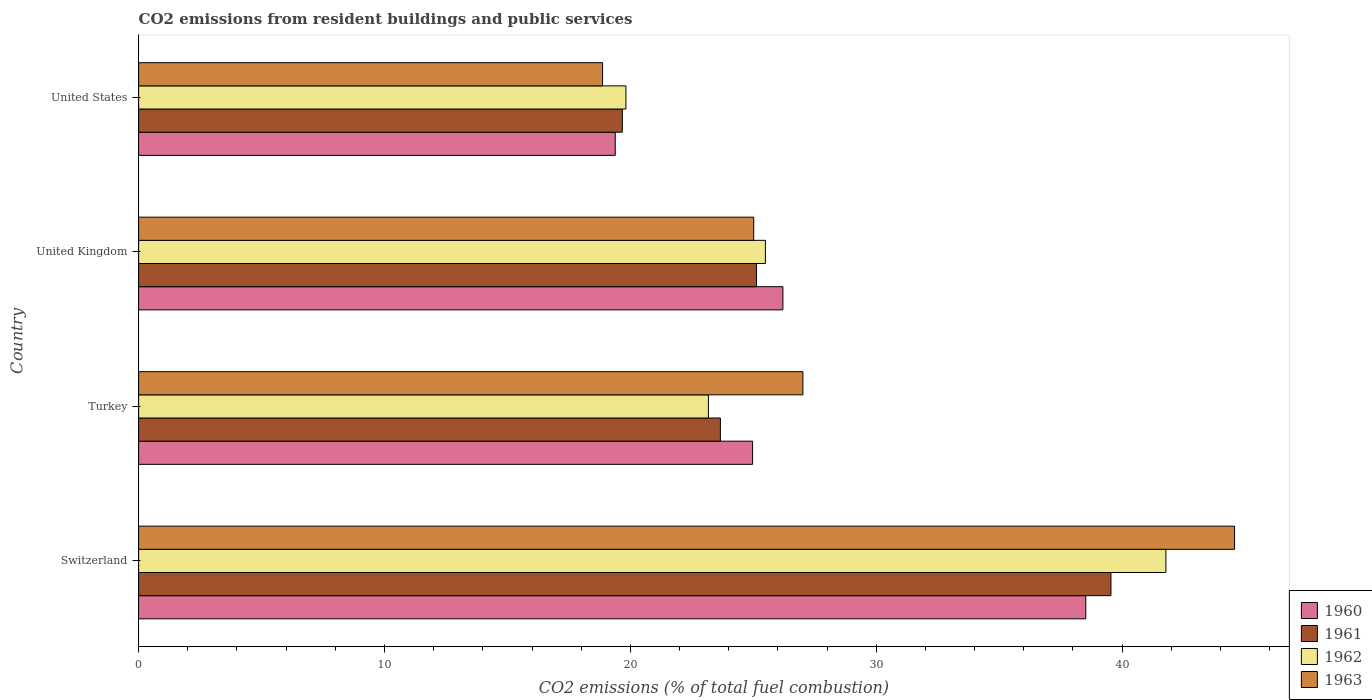How many groups of bars are there?
Make the answer very short. 4. Are the number of bars per tick equal to the number of legend labels?
Keep it short and to the point. Yes. Are the number of bars on each tick of the Y-axis equal?
Offer a terse response. Yes. How many bars are there on the 1st tick from the bottom?
Offer a terse response. 4. In how many cases, is the number of bars for a given country not equal to the number of legend labels?
Provide a short and direct response. 0. What is the total CO2 emitted in 1963 in Switzerland?
Offer a terse response. 44.57. Across all countries, what is the maximum total CO2 emitted in 1960?
Ensure brevity in your answer.  38.52. Across all countries, what is the minimum total CO2 emitted in 1962?
Give a very brief answer. 19.82. In which country was the total CO2 emitted in 1960 maximum?
Your response must be concise. Switzerland. What is the total total CO2 emitted in 1963 in the graph?
Keep it short and to the point. 115.47. What is the difference between the total CO2 emitted in 1961 in Turkey and that in United States?
Give a very brief answer. 3.99. What is the difference between the total CO2 emitted in 1962 in Switzerland and the total CO2 emitted in 1963 in Turkey?
Your answer should be compact. 14.76. What is the average total CO2 emitted in 1962 per country?
Give a very brief answer. 27.57. What is the difference between the total CO2 emitted in 1961 and total CO2 emitted in 1963 in Switzerland?
Your response must be concise. -5.03. What is the ratio of the total CO2 emitted in 1963 in Turkey to that in United Kingdom?
Your response must be concise. 1.08. Is the total CO2 emitted in 1962 in Switzerland less than that in Turkey?
Provide a short and direct response. No. Is the difference between the total CO2 emitted in 1961 in Switzerland and United Kingdom greater than the difference between the total CO2 emitted in 1963 in Switzerland and United Kingdom?
Ensure brevity in your answer.  No. What is the difference between the highest and the second highest total CO2 emitted in 1962?
Your answer should be compact. 16.29. What is the difference between the highest and the lowest total CO2 emitted in 1960?
Offer a very short reply. 19.14. Is it the case that in every country, the sum of the total CO2 emitted in 1962 and total CO2 emitted in 1961 is greater than the total CO2 emitted in 1960?
Your answer should be compact. Yes. What is the difference between two consecutive major ticks on the X-axis?
Provide a short and direct response. 10. Does the graph contain grids?
Your answer should be compact. No. How are the legend labels stacked?
Give a very brief answer. Vertical. What is the title of the graph?
Provide a short and direct response. CO2 emissions from resident buildings and public services. Does "1960" appear as one of the legend labels in the graph?
Ensure brevity in your answer.  Yes. What is the label or title of the X-axis?
Keep it short and to the point. CO2 emissions (% of total fuel combustion). What is the CO2 emissions (% of total fuel combustion) in 1960 in Switzerland?
Provide a succinct answer. 38.52. What is the CO2 emissions (% of total fuel combustion) in 1961 in Switzerland?
Offer a very short reply. 39.54. What is the CO2 emissions (% of total fuel combustion) of 1962 in Switzerland?
Make the answer very short. 41.78. What is the CO2 emissions (% of total fuel combustion) in 1963 in Switzerland?
Your answer should be very brief. 44.57. What is the CO2 emissions (% of total fuel combustion) in 1960 in Turkey?
Provide a succinct answer. 24.97. What is the CO2 emissions (% of total fuel combustion) of 1961 in Turkey?
Ensure brevity in your answer.  23.66. What is the CO2 emissions (% of total fuel combustion) in 1962 in Turkey?
Ensure brevity in your answer.  23.17. What is the CO2 emissions (% of total fuel combustion) in 1963 in Turkey?
Offer a very short reply. 27.01. What is the CO2 emissions (% of total fuel combustion) in 1960 in United Kingdom?
Offer a very short reply. 26.2. What is the CO2 emissions (% of total fuel combustion) of 1961 in United Kingdom?
Give a very brief answer. 25.13. What is the CO2 emissions (% of total fuel combustion) of 1962 in United Kingdom?
Provide a short and direct response. 25.49. What is the CO2 emissions (% of total fuel combustion) of 1963 in United Kingdom?
Your answer should be compact. 25.01. What is the CO2 emissions (% of total fuel combustion) in 1960 in United States?
Ensure brevity in your answer.  19.38. What is the CO2 emissions (% of total fuel combustion) of 1961 in United States?
Offer a terse response. 19.67. What is the CO2 emissions (% of total fuel combustion) in 1962 in United States?
Provide a succinct answer. 19.82. What is the CO2 emissions (% of total fuel combustion) in 1963 in United States?
Provide a succinct answer. 18.87. Across all countries, what is the maximum CO2 emissions (% of total fuel combustion) of 1960?
Provide a succinct answer. 38.52. Across all countries, what is the maximum CO2 emissions (% of total fuel combustion) in 1961?
Your answer should be compact. 39.54. Across all countries, what is the maximum CO2 emissions (% of total fuel combustion) in 1962?
Your response must be concise. 41.78. Across all countries, what is the maximum CO2 emissions (% of total fuel combustion) in 1963?
Ensure brevity in your answer.  44.57. Across all countries, what is the minimum CO2 emissions (% of total fuel combustion) of 1960?
Your response must be concise. 19.38. Across all countries, what is the minimum CO2 emissions (% of total fuel combustion) of 1961?
Your response must be concise. 19.67. Across all countries, what is the minimum CO2 emissions (% of total fuel combustion) of 1962?
Make the answer very short. 19.82. Across all countries, what is the minimum CO2 emissions (% of total fuel combustion) in 1963?
Give a very brief answer. 18.87. What is the total CO2 emissions (% of total fuel combustion) in 1960 in the graph?
Ensure brevity in your answer.  109.08. What is the total CO2 emissions (% of total fuel combustion) of 1961 in the graph?
Your response must be concise. 108. What is the total CO2 emissions (% of total fuel combustion) of 1962 in the graph?
Provide a short and direct response. 110.26. What is the total CO2 emissions (% of total fuel combustion) in 1963 in the graph?
Keep it short and to the point. 115.47. What is the difference between the CO2 emissions (% of total fuel combustion) in 1960 in Switzerland and that in Turkey?
Provide a short and direct response. 13.55. What is the difference between the CO2 emissions (% of total fuel combustion) in 1961 in Switzerland and that in Turkey?
Your answer should be compact. 15.88. What is the difference between the CO2 emissions (% of total fuel combustion) in 1962 in Switzerland and that in Turkey?
Provide a succinct answer. 18.6. What is the difference between the CO2 emissions (% of total fuel combustion) of 1963 in Switzerland and that in Turkey?
Offer a terse response. 17.56. What is the difference between the CO2 emissions (% of total fuel combustion) of 1960 in Switzerland and that in United Kingdom?
Give a very brief answer. 12.32. What is the difference between the CO2 emissions (% of total fuel combustion) in 1961 in Switzerland and that in United Kingdom?
Keep it short and to the point. 14.42. What is the difference between the CO2 emissions (% of total fuel combustion) of 1962 in Switzerland and that in United Kingdom?
Provide a succinct answer. 16.29. What is the difference between the CO2 emissions (% of total fuel combustion) of 1963 in Switzerland and that in United Kingdom?
Give a very brief answer. 19.56. What is the difference between the CO2 emissions (% of total fuel combustion) in 1960 in Switzerland and that in United States?
Your answer should be very brief. 19.14. What is the difference between the CO2 emissions (% of total fuel combustion) in 1961 in Switzerland and that in United States?
Your answer should be compact. 19.87. What is the difference between the CO2 emissions (% of total fuel combustion) of 1962 in Switzerland and that in United States?
Your answer should be very brief. 21.96. What is the difference between the CO2 emissions (% of total fuel combustion) of 1963 in Switzerland and that in United States?
Your response must be concise. 25.7. What is the difference between the CO2 emissions (% of total fuel combustion) in 1960 in Turkey and that in United Kingdom?
Your answer should be compact. -1.23. What is the difference between the CO2 emissions (% of total fuel combustion) of 1961 in Turkey and that in United Kingdom?
Give a very brief answer. -1.47. What is the difference between the CO2 emissions (% of total fuel combustion) in 1962 in Turkey and that in United Kingdom?
Offer a terse response. -2.32. What is the difference between the CO2 emissions (% of total fuel combustion) in 1960 in Turkey and that in United States?
Your answer should be very brief. 5.59. What is the difference between the CO2 emissions (% of total fuel combustion) of 1961 in Turkey and that in United States?
Offer a terse response. 3.99. What is the difference between the CO2 emissions (% of total fuel combustion) in 1962 in Turkey and that in United States?
Provide a short and direct response. 3.36. What is the difference between the CO2 emissions (% of total fuel combustion) of 1963 in Turkey and that in United States?
Provide a short and direct response. 8.15. What is the difference between the CO2 emissions (% of total fuel combustion) in 1960 in United Kingdom and that in United States?
Keep it short and to the point. 6.82. What is the difference between the CO2 emissions (% of total fuel combustion) in 1961 in United Kingdom and that in United States?
Your answer should be compact. 5.46. What is the difference between the CO2 emissions (% of total fuel combustion) of 1962 in United Kingdom and that in United States?
Make the answer very short. 5.67. What is the difference between the CO2 emissions (% of total fuel combustion) in 1963 in United Kingdom and that in United States?
Offer a terse response. 6.15. What is the difference between the CO2 emissions (% of total fuel combustion) of 1960 in Switzerland and the CO2 emissions (% of total fuel combustion) of 1961 in Turkey?
Provide a succinct answer. 14.86. What is the difference between the CO2 emissions (% of total fuel combustion) in 1960 in Switzerland and the CO2 emissions (% of total fuel combustion) in 1962 in Turkey?
Your response must be concise. 15.35. What is the difference between the CO2 emissions (% of total fuel combustion) in 1960 in Switzerland and the CO2 emissions (% of total fuel combustion) in 1963 in Turkey?
Offer a very short reply. 11.51. What is the difference between the CO2 emissions (% of total fuel combustion) of 1961 in Switzerland and the CO2 emissions (% of total fuel combustion) of 1962 in Turkey?
Offer a terse response. 16.37. What is the difference between the CO2 emissions (% of total fuel combustion) of 1961 in Switzerland and the CO2 emissions (% of total fuel combustion) of 1963 in Turkey?
Provide a succinct answer. 12.53. What is the difference between the CO2 emissions (% of total fuel combustion) of 1962 in Switzerland and the CO2 emissions (% of total fuel combustion) of 1963 in Turkey?
Offer a terse response. 14.76. What is the difference between the CO2 emissions (% of total fuel combustion) of 1960 in Switzerland and the CO2 emissions (% of total fuel combustion) of 1961 in United Kingdom?
Keep it short and to the point. 13.39. What is the difference between the CO2 emissions (% of total fuel combustion) of 1960 in Switzerland and the CO2 emissions (% of total fuel combustion) of 1962 in United Kingdom?
Make the answer very short. 13.03. What is the difference between the CO2 emissions (% of total fuel combustion) of 1960 in Switzerland and the CO2 emissions (% of total fuel combustion) of 1963 in United Kingdom?
Your answer should be very brief. 13.51. What is the difference between the CO2 emissions (% of total fuel combustion) of 1961 in Switzerland and the CO2 emissions (% of total fuel combustion) of 1962 in United Kingdom?
Provide a short and direct response. 14.05. What is the difference between the CO2 emissions (% of total fuel combustion) in 1961 in Switzerland and the CO2 emissions (% of total fuel combustion) in 1963 in United Kingdom?
Offer a terse response. 14.53. What is the difference between the CO2 emissions (% of total fuel combustion) of 1962 in Switzerland and the CO2 emissions (% of total fuel combustion) of 1963 in United Kingdom?
Make the answer very short. 16.76. What is the difference between the CO2 emissions (% of total fuel combustion) in 1960 in Switzerland and the CO2 emissions (% of total fuel combustion) in 1961 in United States?
Ensure brevity in your answer.  18.85. What is the difference between the CO2 emissions (% of total fuel combustion) of 1960 in Switzerland and the CO2 emissions (% of total fuel combustion) of 1962 in United States?
Keep it short and to the point. 18.7. What is the difference between the CO2 emissions (% of total fuel combustion) in 1960 in Switzerland and the CO2 emissions (% of total fuel combustion) in 1963 in United States?
Provide a short and direct response. 19.65. What is the difference between the CO2 emissions (% of total fuel combustion) of 1961 in Switzerland and the CO2 emissions (% of total fuel combustion) of 1962 in United States?
Keep it short and to the point. 19.73. What is the difference between the CO2 emissions (% of total fuel combustion) of 1961 in Switzerland and the CO2 emissions (% of total fuel combustion) of 1963 in United States?
Make the answer very short. 20.68. What is the difference between the CO2 emissions (% of total fuel combustion) of 1962 in Switzerland and the CO2 emissions (% of total fuel combustion) of 1963 in United States?
Ensure brevity in your answer.  22.91. What is the difference between the CO2 emissions (% of total fuel combustion) in 1960 in Turkey and the CO2 emissions (% of total fuel combustion) in 1961 in United Kingdom?
Give a very brief answer. -0.16. What is the difference between the CO2 emissions (% of total fuel combustion) of 1960 in Turkey and the CO2 emissions (% of total fuel combustion) of 1962 in United Kingdom?
Give a very brief answer. -0.52. What is the difference between the CO2 emissions (% of total fuel combustion) of 1960 in Turkey and the CO2 emissions (% of total fuel combustion) of 1963 in United Kingdom?
Your answer should be compact. -0.05. What is the difference between the CO2 emissions (% of total fuel combustion) of 1961 in Turkey and the CO2 emissions (% of total fuel combustion) of 1962 in United Kingdom?
Your answer should be compact. -1.83. What is the difference between the CO2 emissions (% of total fuel combustion) of 1961 in Turkey and the CO2 emissions (% of total fuel combustion) of 1963 in United Kingdom?
Your response must be concise. -1.35. What is the difference between the CO2 emissions (% of total fuel combustion) of 1962 in Turkey and the CO2 emissions (% of total fuel combustion) of 1963 in United Kingdom?
Your response must be concise. -1.84. What is the difference between the CO2 emissions (% of total fuel combustion) of 1960 in Turkey and the CO2 emissions (% of total fuel combustion) of 1961 in United States?
Your answer should be very brief. 5.3. What is the difference between the CO2 emissions (% of total fuel combustion) in 1960 in Turkey and the CO2 emissions (% of total fuel combustion) in 1962 in United States?
Offer a very short reply. 5.15. What is the difference between the CO2 emissions (% of total fuel combustion) of 1960 in Turkey and the CO2 emissions (% of total fuel combustion) of 1963 in United States?
Provide a short and direct response. 6.1. What is the difference between the CO2 emissions (% of total fuel combustion) of 1961 in Turkey and the CO2 emissions (% of total fuel combustion) of 1962 in United States?
Your answer should be very brief. 3.84. What is the difference between the CO2 emissions (% of total fuel combustion) of 1961 in Turkey and the CO2 emissions (% of total fuel combustion) of 1963 in United States?
Your answer should be compact. 4.79. What is the difference between the CO2 emissions (% of total fuel combustion) of 1962 in Turkey and the CO2 emissions (% of total fuel combustion) of 1963 in United States?
Offer a very short reply. 4.3. What is the difference between the CO2 emissions (% of total fuel combustion) in 1960 in United Kingdom and the CO2 emissions (% of total fuel combustion) in 1961 in United States?
Keep it short and to the point. 6.53. What is the difference between the CO2 emissions (% of total fuel combustion) of 1960 in United Kingdom and the CO2 emissions (% of total fuel combustion) of 1962 in United States?
Keep it short and to the point. 6.38. What is the difference between the CO2 emissions (% of total fuel combustion) in 1960 in United Kingdom and the CO2 emissions (% of total fuel combustion) in 1963 in United States?
Provide a succinct answer. 7.33. What is the difference between the CO2 emissions (% of total fuel combustion) of 1961 in United Kingdom and the CO2 emissions (% of total fuel combustion) of 1962 in United States?
Your answer should be very brief. 5.31. What is the difference between the CO2 emissions (% of total fuel combustion) in 1961 in United Kingdom and the CO2 emissions (% of total fuel combustion) in 1963 in United States?
Make the answer very short. 6.26. What is the difference between the CO2 emissions (% of total fuel combustion) in 1962 in United Kingdom and the CO2 emissions (% of total fuel combustion) in 1963 in United States?
Offer a terse response. 6.62. What is the average CO2 emissions (% of total fuel combustion) in 1960 per country?
Offer a very short reply. 27.27. What is the average CO2 emissions (% of total fuel combustion) in 1961 per country?
Provide a short and direct response. 27. What is the average CO2 emissions (% of total fuel combustion) in 1962 per country?
Keep it short and to the point. 27.57. What is the average CO2 emissions (% of total fuel combustion) in 1963 per country?
Your answer should be compact. 28.87. What is the difference between the CO2 emissions (% of total fuel combustion) of 1960 and CO2 emissions (% of total fuel combustion) of 1961 in Switzerland?
Your response must be concise. -1.02. What is the difference between the CO2 emissions (% of total fuel combustion) in 1960 and CO2 emissions (% of total fuel combustion) in 1962 in Switzerland?
Offer a very short reply. -3.26. What is the difference between the CO2 emissions (% of total fuel combustion) of 1960 and CO2 emissions (% of total fuel combustion) of 1963 in Switzerland?
Ensure brevity in your answer.  -6.05. What is the difference between the CO2 emissions (% of total fuel combustion) in 1961 and CO2 emissions (% of total fuel combustion) in 1962 in Switzerland?
Your answer should be very brief. -2.23. What is the difference between the CO2 emissions (% of total fuel combustion) of 1961 and CO2 emissions (% of total fuel combustion) of 1963 in Switzerland?
Your answer should be very brief. -5.03. What is the difference between the CO2 emissions (% of total fuel combustion) in 1962 and CO2 emissions (% of total fuel combustion) in 1963 in Switzerland?
Make the answer very short. -2.79. What is the difference between the CO2 emissions (% of total fuel combustion) of 1960 and CO2 emissions (% of total fuel combustion) of 1961 in Turkey?
Make the answer very short. 1.31. What is the difference between the CO2 emissions (% of total fuel combustion) in 1960 and CO2 emissions (% of total fuel combustion) in 1962 in Turkey?
Offer a terse response. 1.8. What is the difference between the CO2 emissions (% of total fuel combustion) in 1960 and CO2 emissions (% of total fuel combustion) in 1963 in Turkey?
Your answer should be very brief. -2.05. What is the difference between the CO2 emissions (% of total fuel combustion) in 1961 and CO2 emissions (% of total fuel combustion) in 1962 in Turkey?
Your answer should be very brief. 0.49. What is the difference between the CO2 emissions (% of total fuel combustion) of 1961 and CO2 emissions (% of total fuel combustion) of 1963 in Turkey?
Offer a terse response. -3.35. What is the difference between the CO2 emissions (% of total fuel combustion) in 1962 and CO2 emissions (% of total fuel combustion) in 1963 in Turkey?
Keep it short and to the point. -3.84. What is the difference between the CO2 emissions (% of total fuel combustion) of 1960 and CO2 emissions (% of total fuel combustion) of 1961 in United Kingdom?
Offer a very short reply. 1.07. What is the difference between the CO2 emissions (% of total fuel combustion) of 1960 and CO2 emissions (% of total fuel combustion) of 1962 in United Kingdom?
Offer a terse response. 0.71. What is the difference between the CO2 emissions (% of total fuel combustion) of 1960 and CO2 emissions (% of total fuel combustion) of 1963 in United Kingdom?
Give a very brief answer. 1.19. What is the difference between the CO2 emissions (% of total fuel combustion) of 1961 and CO2 emissions (% of total fuel combustion) of 1962 in United Kingdom?
Your answer should be compact. -0.36. What is the difference between the CO2 emissions (% of total fuel combustion) in 1961 and CO2 emissions (% of total fuel combustion) in 1963 in United Kingdom?
Make the answer very short. 0.11. What is the difference between the CO2 emissions (% of total fuel combustion) of 1962 and CO2 emissions (% of total fuel combustion) of 1963 in United Kingdom?
Provide a short and direct response. 0.48. What is the difference between the CO2 emissions (% of total fuel combustion) of 1960 and CO2 emissions (% of total fuel combustion) of 1961 in United States?
Your answer should be very brief. -0.29. What is the difference between the CO2 emissions (% of total fuel combustion) of 1960 and CO2 emissions (% of total fuel combustion) of 1962 in United States?
Provide a short and direct response. -0.43. What is the difference between the CO2 emissions (% of total fuel combustion) in 1960 and CO2 emissions (% of total fuel combustion) in 1963 in United States?
Offer a terse response. 0.52. What is the difference between the CO2 emissions (% of total fuel combustion) of 1961 and CO2 emissions (% of total fuel combustion) of 1962 in United States?
Provide a succinct answer. -0.15. What is the difference between the CO2 emissions (% of total fuel combustion) of 1961 and CO2 emissions (% of total fuel combustion) of 1963 in United States?
Your answer should be very brief. 0.8. What is the difference between the CO2 emissions (% of total fuel combustion) of 1962 and CO2 emissions (% of total fuel combustion) of 1963 in United States?
Provide a succinct answer. 0.95. What is the ratio of the CO2 emissions (% of total fuel combustion) of 1960 in Switzerland to that in Turkey?
Give a very brief answer. 1.54. What is the ratio of the CO2 emissions (% of total fuel combustion) in 1961 in Switzerland to that in Turkey?
Your answer should be compact. 1.67. What is the ratio of the CO2 emissions (% of total fuel combustion) in 1962 in Switzerland to that in Turkey?
Your response must be concise. 1.8. What is the ratio of the CO2 emissions (% of total fuel combustion) in 1963 in Switzerland to that in Turkey?
Give a very brief answer. 1.65. What is the ratio of the CO2 emissions (% of total fuel combustion) in 1960 in Switzerland to that in United Kingdom?
Offer a very short reply. 1.47. What is the ratio of the CO2 emissions (% of total fuel combustion) of 1961 in Switzerland to that in United Kingdom?
Provide a succinct answer. 1.57. What is the ratio of the CO2 emissions (% of total fuel combustion) of 1962 in Switzerland to that in United Kingdom?
Ensure brevity in your answer.  1.64. What is the ratio of the CO2 emissions (% of total fuel combustion) of 1963 in Switzerland to that in United Kingdom?
Your response must be concise. 1.78. What is the ratio of the CO2 emissions (% of total fuel combustion) of 1960 in Switzerland to that in United States?
Keep it short and to the point. 1.99. What is the ratio of the CO2 emissions (% of total fuel combustion) in 1961 in Switzerland to that in United States?
Your answer should be compact. 2.01. What is the ratio of the CO2 emissions (% of total fuel combustion) in 1962 in Switzerland to that in United States?
Your response must be concise. 2.11. What is the ratio of the CO2 emissions (% of total fuel combustion) in 1963 in Switzerland to that in United States?
Make the answer very short. 2.36. What is the ratio of the CO2 emissions (% of total fuel combustion) in 1960 in Turkey to that in United Kingdom?
Offer a very short reply. 0.95. What is the ratio of the CO2 emissions (% of total fuel combustion) in 1961 in Turkey to that in United Kingdom?
Your answer should be very brief. 0.94. What is the ratio of the CO2 emissions (% of total fuel combustion) in 1962 in Turkey to that in United Kingdom?
Provide a short and direct response. 0.91. What is the ratio of the CO2 emissions (% of total fuel combustion) of 1960 in Turkey to that in United States?
Make the answer very short. 1.29. What is the ratio of the CO2 emissions (% of total fuel combustion) of 1961 in Turkey to that in United States?
Offer a terse response. 1.2. What is the ratio of the CO2 emissions (% of total fuel combustion) in 1962 in Turkey to that in United States?
Your response must be concise. 1.17. What is the ratio of the CO2 emissions (% of total fuel combustion) in 1963 in Turkey to that in United States?
Provide a succinct answer. 1.43. What is the ratio of the CO2 emissions (% of total fuel combustion) in 1960 in United Kingdom to that in United States?
Keep it short and to the point. 1.35. What is the ratio of the CO2 emissions (% of total fuel combustion) in 1961 in United Kingdom to that in United States?
Your answer should be compact. 1.28. What is the ratio of the CO2 emissions (% of total fuel combustion) of 1962 in United Kingdom to that in United States?
Your response must be concise. 1.29. What is the ratio of the CO2 emissions (% of total fuel combustion) of 1963 in United Kingdom to that in United States?
Offer a very short reply. 1.33. What is the difference between the highest and the second highest CO2 emissions (% of total fuel combustion) in 1960?
Make the answer very short. 12.32. What is the difference between the highest and the second highest CO2 emissions (% of total fuel combustion) in 1961?
Provide a short and direct response. 14.42. What is the difference between the highest and the second highest CO2 emissions (% of total fuel combustion) of 1962?
Give a very brief answer. 16.29. What is the difference between the highest and the second highest CO2 emissions (% of total fuel combustion) in 1963?
Keep it short and to the point. 17.56. What is the difference between the highest and the lowest CO2 emissions (% of total fuel combustion) in 1960?
Ensure brevity in your answer.  19.14. What is the difference between the highest and the lowest CO2 emissions (% of total fuel combustion) in 1961?
Your answer should be compact. 19.87. What is the difference between the highest and the lowest CO2 emissions (% of total fuel combustion) of 1962?
Your response must be concise. 21.96. What is the difference between the highest and the lowest CO2 emissions (% of total fuel combustion) in 1963?
Make the answer very short. 25.7. 